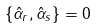<formula> <loc_0><loc_0><loc_500><loc_500>\{ \hat { \alpha } _ { r } , \hat { \alpha } _ { s } \} = 0</formula> 